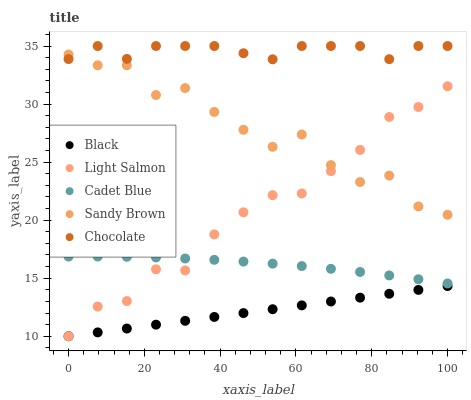Does Black have the minimum area under the curve?
Answer yes or no. Yes. Does Chocolate have the maximum area under the curve?
Answer yes or no. Yes. Does Light Salmon have the minimum area under the curve?
Answer yes or no. No. Does Light Salmon have the maximum area under the curve?
Answer yes or no. No. Is Black the smoothest?
Answer yes or no. Yes. Is Sandy Brown the roughest?
Answer yes or no. Yes. Is Light Salmon the smoothest?
Answer yes or no. No. Is Light Salmon the roughest?
Answer yes or no. No. Does Light Salmon have the lowest value?
Answer yes or no. Yes. Does Cadet Blue have the lowest value?
Answer yes or no. No. Does Chocolate have the highest value?
Answer yes or no. Yes. Does Light Salmon have the highest value?
Answer yes or no. No. Is Cadet Blue less than Sandy Brown?
Answer yes or no. Yes. Is Chocolate greater than Light Salmon?
Answer yes or no. Yes. Does Light Salmon intersect Black?
Answer yes or no. Yes. Is Light Salmon less than Black?
Answer yes or no. No. Is Light Salmon greater than Black?
Answer yes or no. No. Does Cadet Blue intersect Sandy Brown?
Answer yes or no. No. 